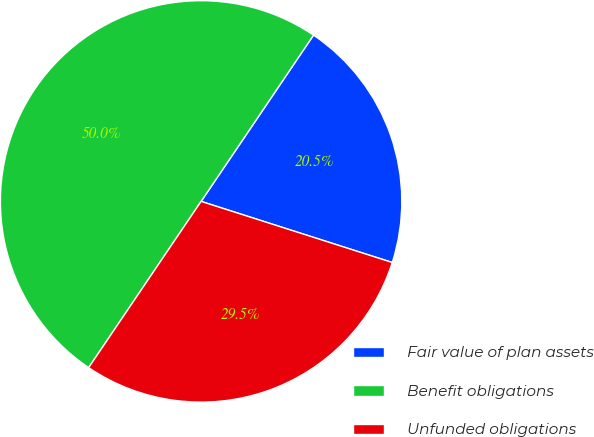<chart> <loc_0><loc_0><loc_500><loc_500><pie_chart><fcel>Fair value of plan assets<fcel>Benefit obligations<fcel>Unfunded obligations<nl><fcel>20.46%<fcel>50.0%<fcel>29.54%<nl></chart> 